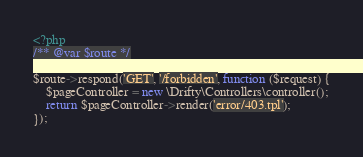<code> <loc_0><loc_0><loc_500><loc_500><_PHP_><?php
/** @var $route */

$route->respond('GET', '/forbidden', function ($request) {
    $pageController = new \Drifty\Controllers\controller();
    return $pageController->render('error/403.tpl');
});</code> 